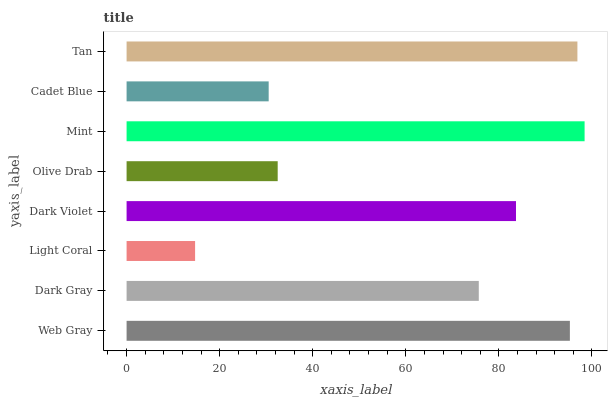Is Light Coral the minimum?
Answer yes or no. Yes. Is Mint the maximum?
Answer yes or no. Yes. Is Dark Gray the minimum?
Answer yes or no. No. Is Dark Gray the maximum?
Answer yes or no. No. Is Web Gray greater than Dark Gray?
Answer yes or no. Yes. Is Dark Gray less than Web Gray?
Answer yes or no. Yes. Is Dark Gray greater than Web Gray?
Answer yes or no. No. Is Web Gray less than Dark Gray?
Answer yes or no. No. Is Dark Violet the high median?
Answer yes or no. Yes. Is Dark Gray the low median?
Answer yes or no. Yes. Is Cadet Blue the high median?
Answer yes or no. No. Is Light Coral the low median?
Answer yes or no. No. 